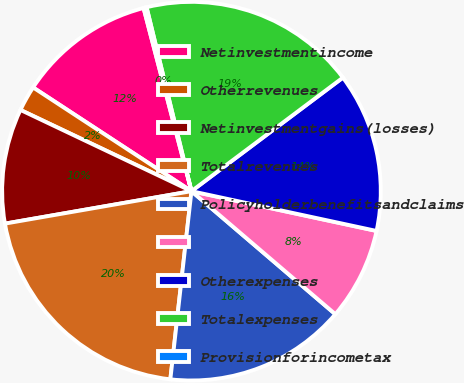Convert chart to OTSL. <chart><loc_0><loc_0><loc_500><loc_500><pie_chart><fcel>Netinvestmentincome<fcel>Otherrevenues<fcel>Netinvestmentgains(losses)<fcel>Totalrevenues<fcel>Policyholderbenefitsandclaims<fcel>Unnamed: 5<fcel>Otherexpenses<fcel>Totalexpenses<fcel>Provisionforincometax<nl><fcel>11.7%<fcel>2.17%<fcel>9.8%<fcel>20.48%<fcel>15.52%<fcel>7.89%<fcel>13.61%<fcel>18.57%<fcel>0.26%<nl></chart> 